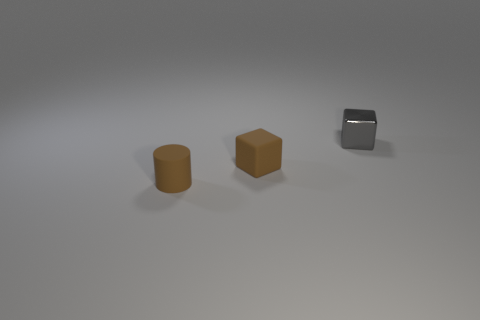Is the color of the tiny rubber block the same as the tiny cylinder?
Your answer should be compact. Yes. There is a tiny cube that is in front of the tiny gray object; is it the same color as the small cylinder?
Make the answer very short. Yes. What number of tiny objects are in front of the gray cube and right of the tiny brown rubber cylinder?
Provide a short and direct response. 1. How many objects are brown cubes or brown rubber cylinders that are in front of the small brown rubber cube?
Offer a terse response. 2. There is a small rubber object that is the same color as the tiny matte cylinder; what is its shape?
Your answer should be compact. Cube. There is a block that is left of the gray metallic block; what color is it?
Your answer should be compact. Brown. What number of things are either brown cylinders that are in front of the small gray metallic cube or small brown objects?
Offer a very short reply. 2. There is a matte cylinder that is the same size as the gray thing; what is its color?
Offer a very short reply. Brown. Is the number of brown matte cylinders to the left of the small gray shiny object greater than the number of purple shiny cylinders?
Your answer should be compact. Yes. Does the matte thing that is behind the brown rubber cylinder have the same color as the small object to the left of the brown block?
Your answer should be compact. Yes. 